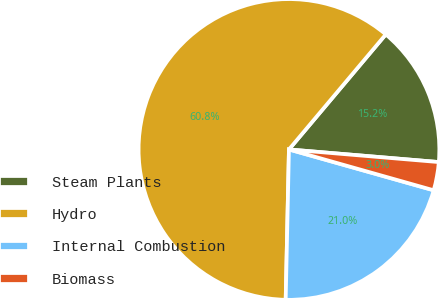<chart> <loc_0><loc_0><loc_500><loc_500><pie_chart><fcel>Steam Plants<fcel>Hydro<fcel>Internal Combustion<fcel>Biomass<nl><fcel>15.2%<fcel>60.79%<fcel>20.97%<fcel>3.04%<nl></chart> 